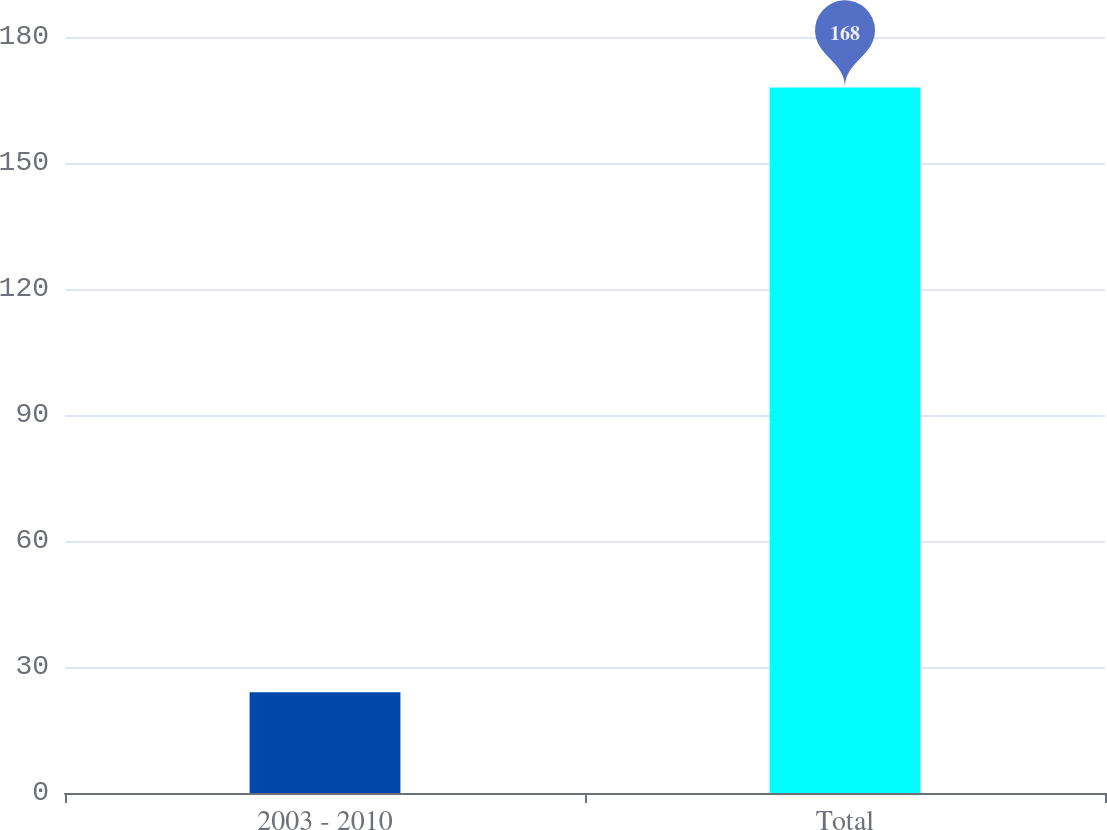Convert chart. <chart><loc_0><loc_0><loc_500><loc_500><bar_chart><fcel>2003 - 2010<fcel>Total<nl><fcel>24<fcel>168<nl></chart> 